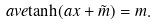Convert formula to latex. <formula><loc_0><loc_0><loc_500><loc_500>\ a v e { \tanh ( a x + \tilde { m } ) } = m .</formula> 